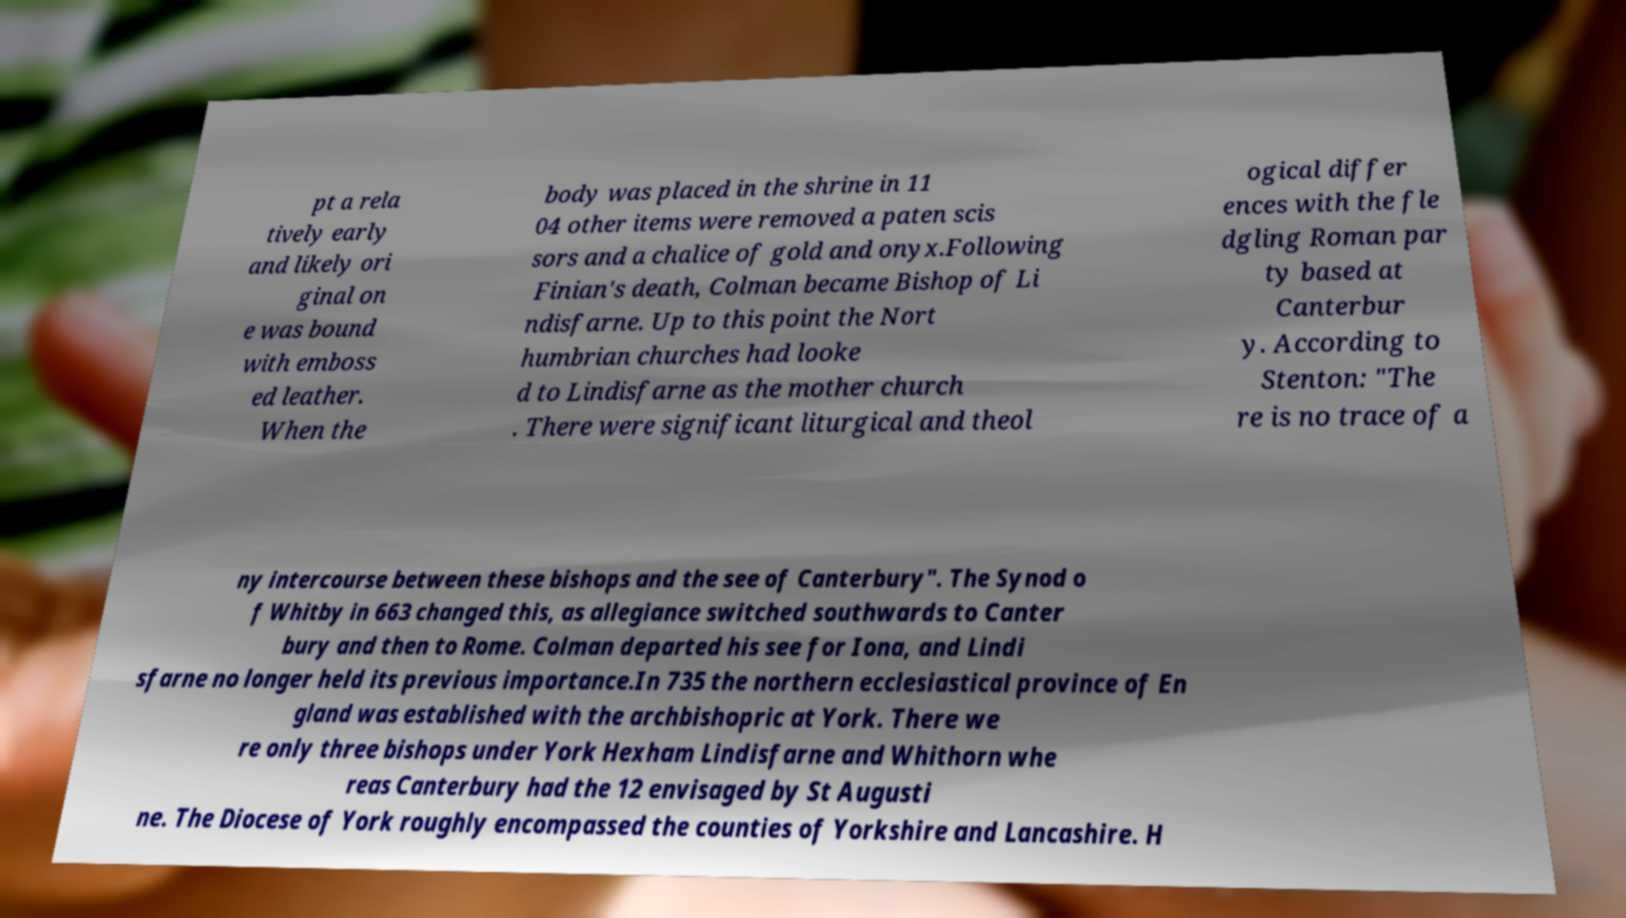What messages or text are displayed in this image? I need them in a readable, typed format. pt a rela tively early and likely ori ginal on e was bound with emboss ed leather. When the body was placed in the shrine in 11 04 other items were removed a paten scis sors and a chalice of gold and onyx.Following Finian's death, Colman became Bishop of Li ndisfarne. Up to this point the Nort humbrian churches had looke d to Lindisfarne as the mother church . There were significant liturgical and theol ogical differ ences with the fle dgling Roman par ty based at Canterbur y. According to Stenton: "The re is no trace of a ny intercourse between these bishops and the see of Canterbury". The Synod o f Whitby in 663 changed this, as allegiance switched southwards to Canter bury and then to Rome. Colman departed his see for Iona, and Lindi sfarne no longer held its previous importance.In 735 the northern ecclesiastical province of En gland was established with the archbishopric at York. There we re only three bishops under York Hexham Lindisfarne and Whithorn whe reas Canterbury had the 12 envisaged by St Augusti ne. The Diocese of York roughly encompassed the counties of Yorkshire and Lancashire. H 